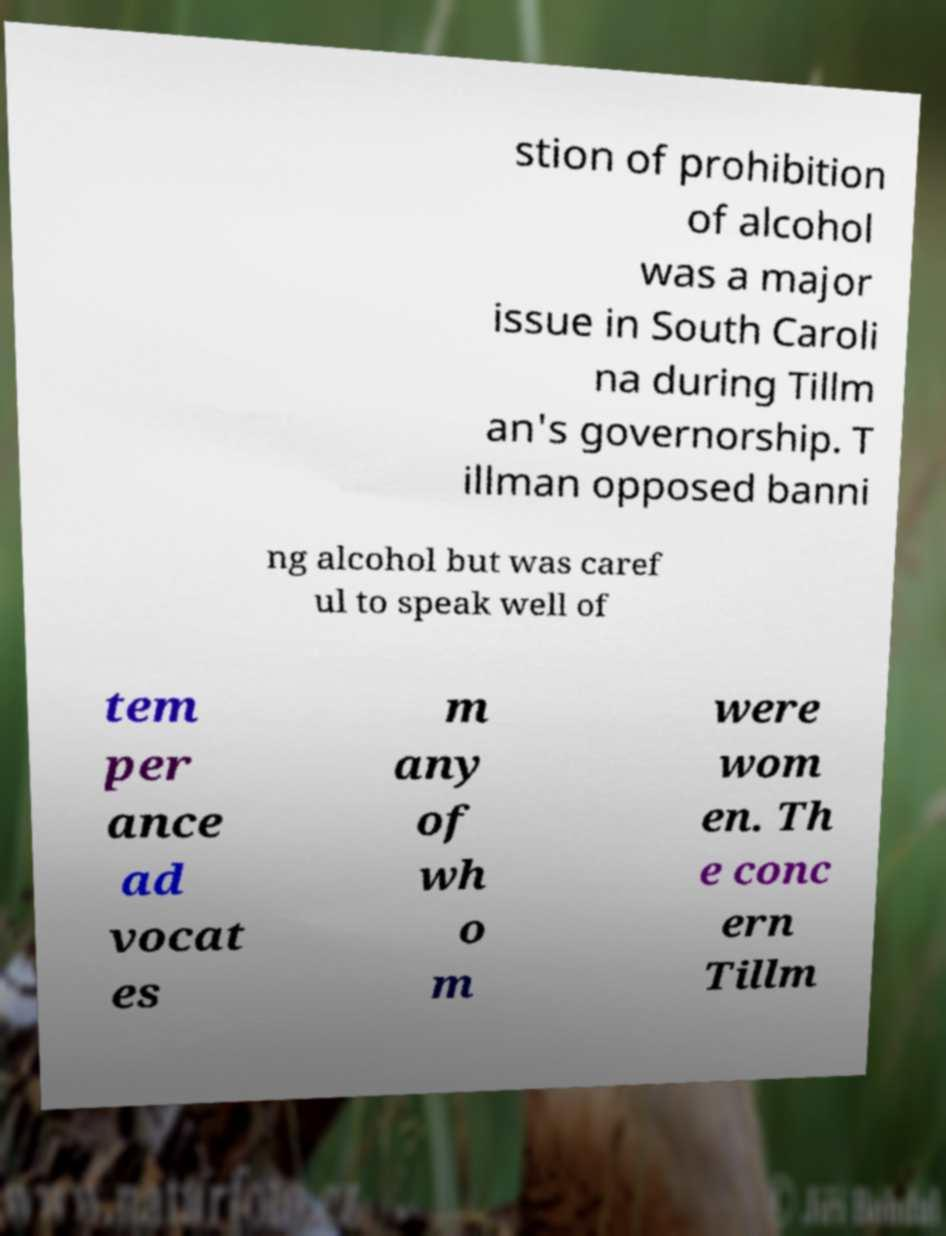Please identify and transcribe the text found in this image. stion of prohibition of alcohol was a major issue in South Caroli na during Tillm an's governorship. T illman opposed banni ng alcohol but was caref ul to speak well of tem per ance ad vocat es m any of wh o m were wom en. Th e conc ern Tillm 